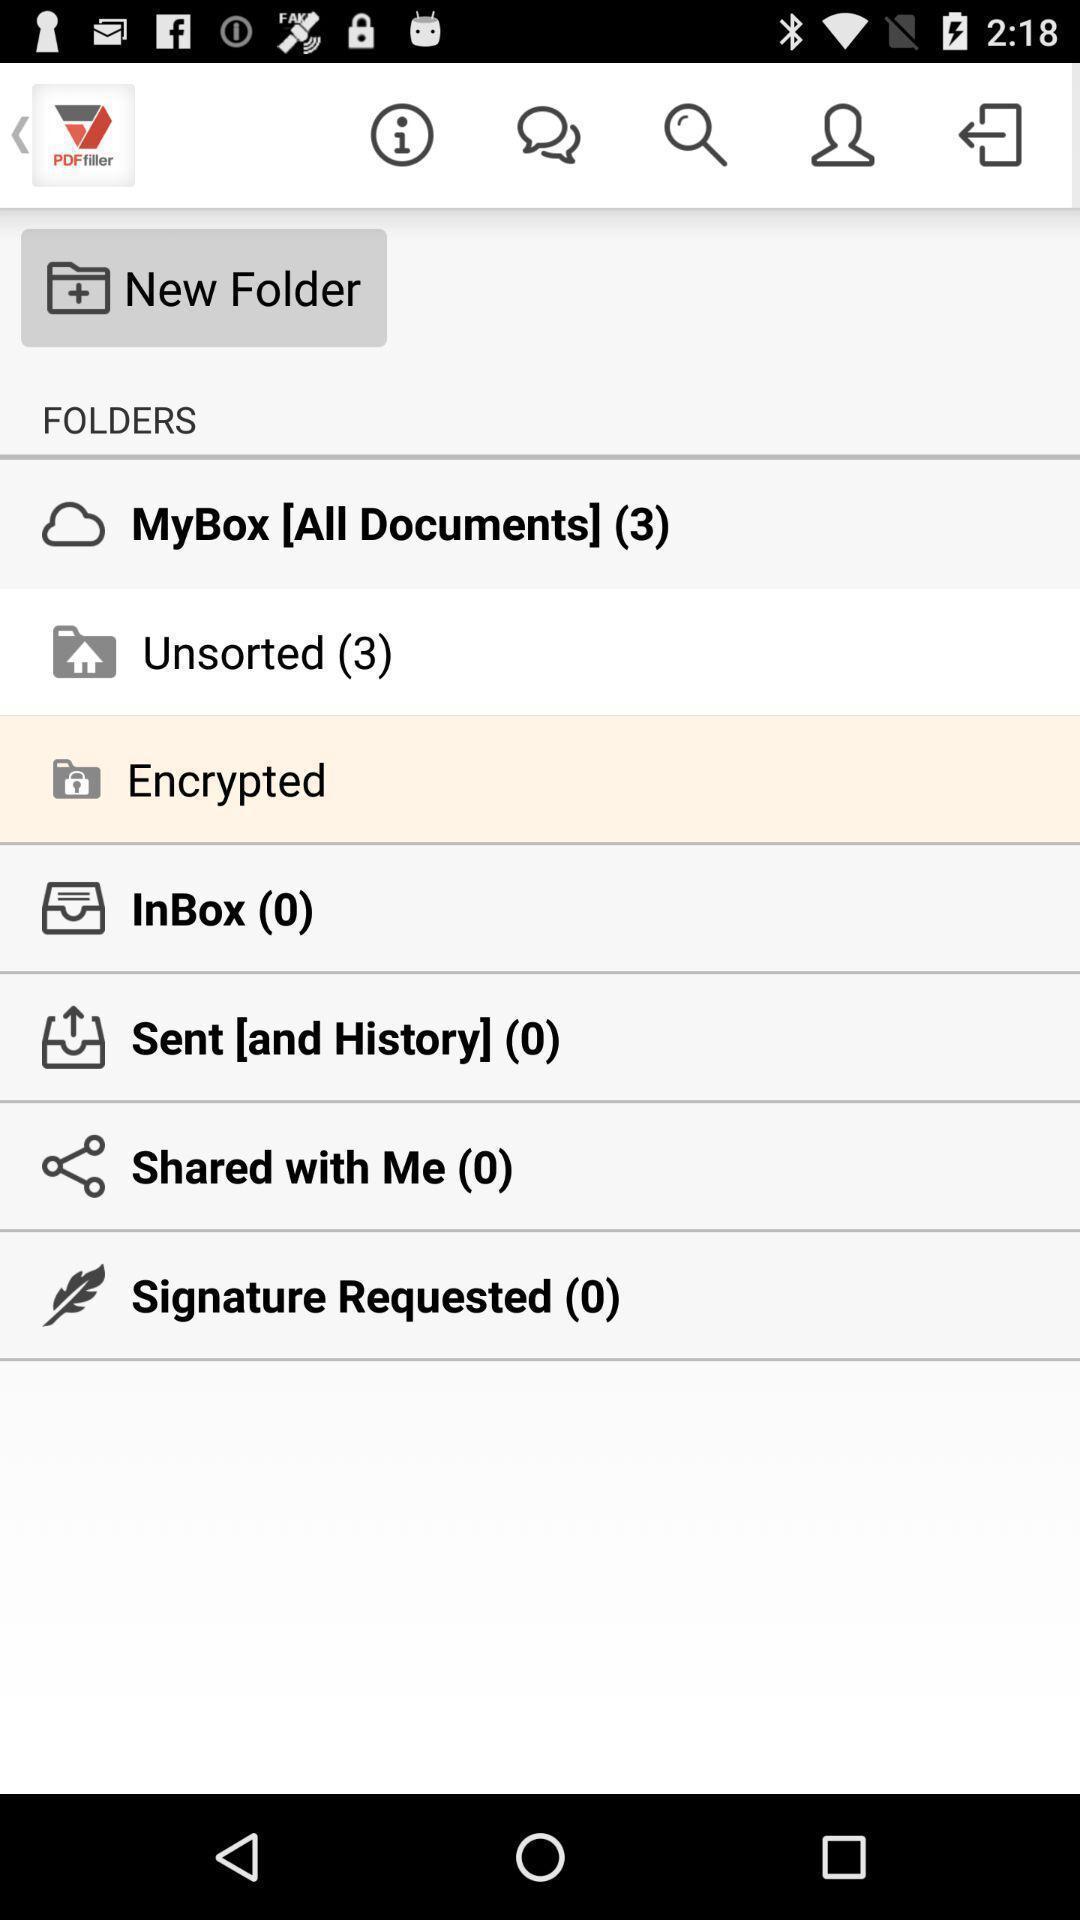Summarize the information in this screenshot. Screen page with various options in learning application. 